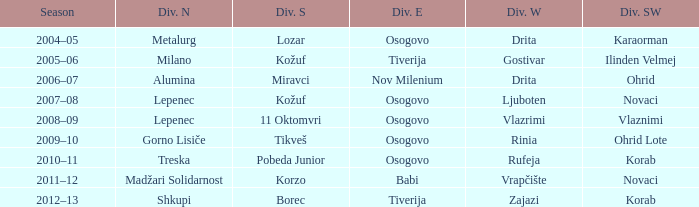Who won Division West when Division North was won by Alumina? Drita. 